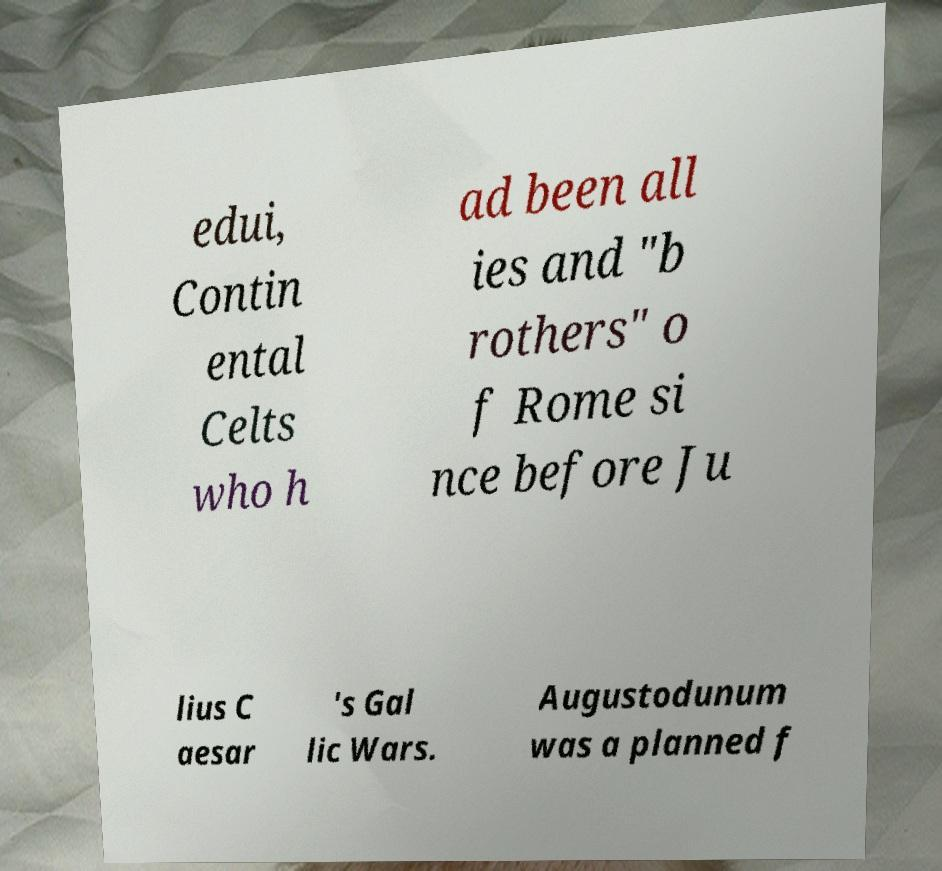Could you assist in decoding the text presented in this image and type it out clearly? edui, Contin ental Celts who h ad been all ies and "b rothers" o f Rome si nce before Ju lius C aesar 's Gal lic Wars. Augustodunum was a planned f 